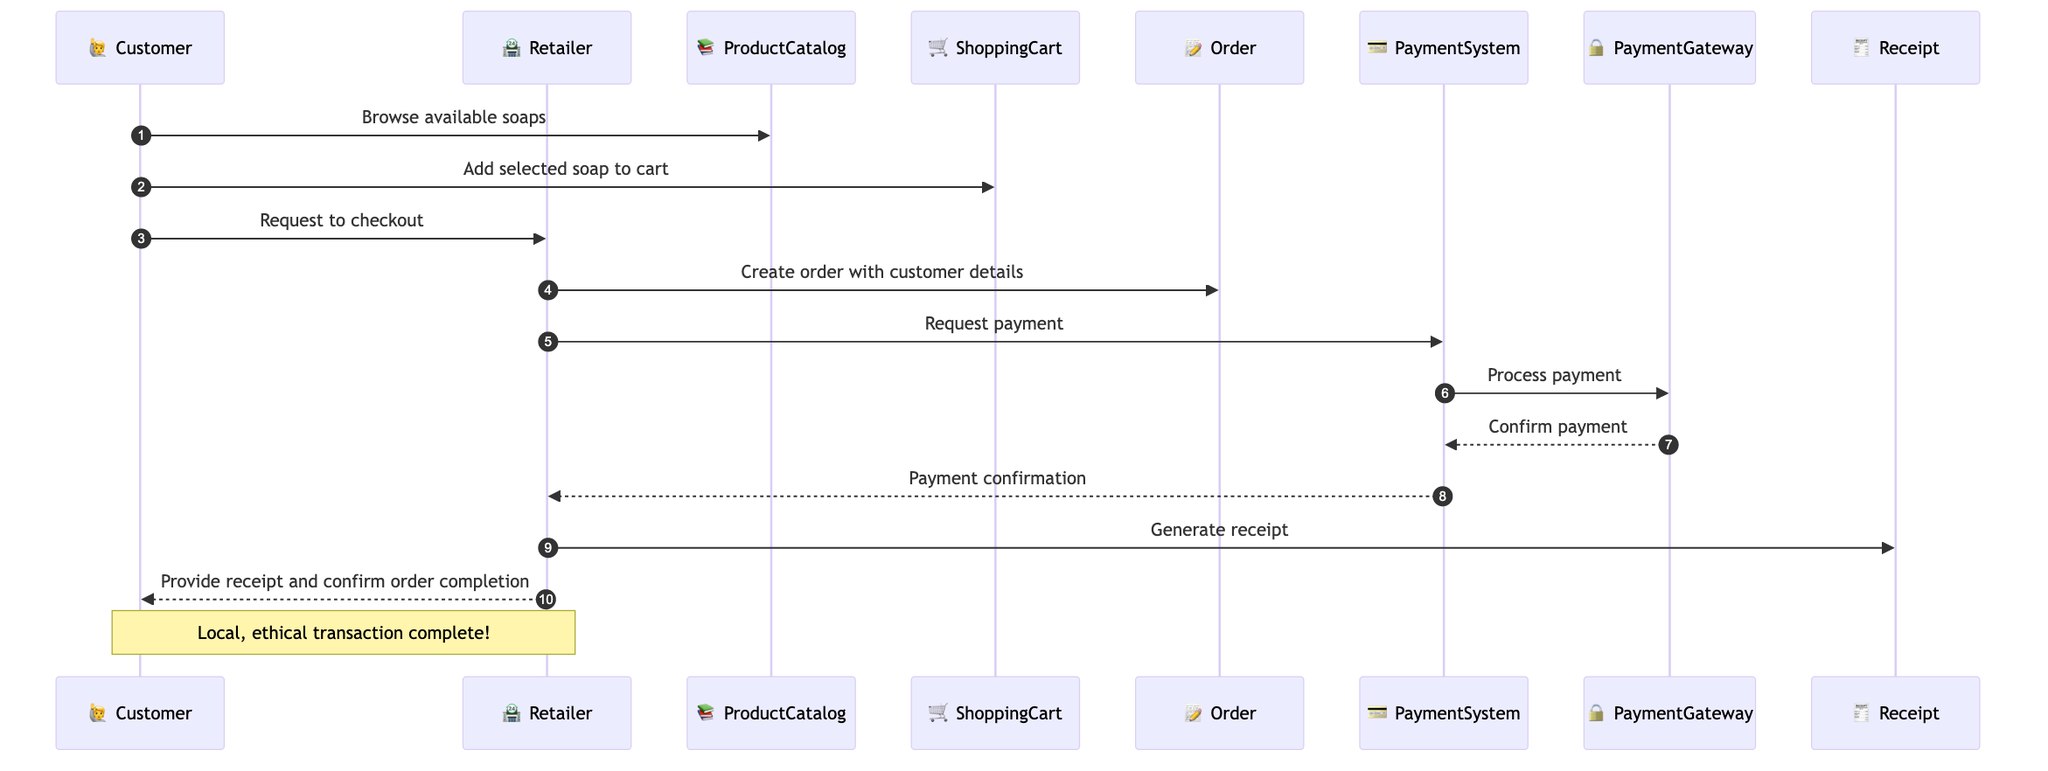What are the actors involved in the process? The actors in the diagram include the Customer, Retailer, and Payment System. These are the main participants engaging in the transaction.
Answer: Customer, Retailer, Payment System How many interactions are there in the diagram? Counting the interactions listed, there are ten distinct messages conveyed between the actors and objects of the diagram.
Answer: Ten What does the Customer do after browsing available soaps? After browsing, the Customer adds the selected soap to the Shopping Cart as the next step in the interaction sequence.
Answer: Add selected soap to cart Which object does the Retailer create order with? The Retailer creates the order with customer details, thereby interacting specifically with the Order object.
Answer: Order What is the final confirmation given to the Customer? At the end of the transaction, the final confirmation to the Customer is the receipt along with the confirmation of order completion.
Answer: Provide receipt and confirm order completion What entity does the PaymentSystem request payment from? The PaymentSystem requests payment from the Payment Gateway, which handles the actual processing of the transaction.
Answer: Payment Gateway In which step does the Retailer generate the receipt? The Retailer generates the receipt after receiving confirmation of payment from the Payment System, marking a crucial step in completing the order process.
Answer: Generate receipt What is the main purpose of the Payment Gateway in this sequence? The main purpose of the Payment Gateway is to process the payment, ensuring the transaction is carried out securely and effectively for the Retailer.
Answer: Process payment How does the Customer initiate the purchasing process? The Customer initiates the purchasing process by browsing the available soaps listed in the Product Catalog, which starts the interaction sequence.
Answer: Browse available soaps What type of transaction is indicated by the note over the Customer and Retailer? The note indicates that the transaction is local and ethical, emphasizing the nature of the interaction between the Customer and Retailer in this context.
Answer: Local, ethical transaction 